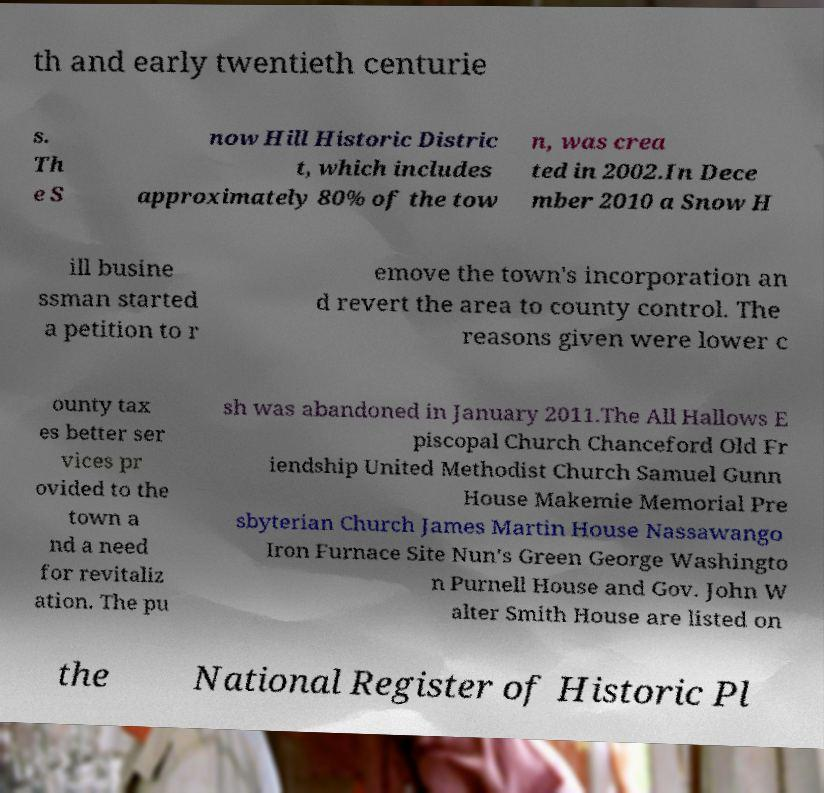Could you extract and type out the text from this image? th and early twentieth centurie s. Th e S now Hill Historic Distric t, which includes approximately 80% of the tow n, was crea ted in 2002.In Dece mber 2010 a Snow H ill busine ssman started a petition to r emove the town's incorporation an d revert the area to county control. The reasons given were lower c ounty tax es better ser vices pr ovided to the town a nd a need for revitaliz ation. The pu sh was abandoned in January 2011.The All Hallows E piscopal Church Chanceford Old Fr iendship United Methodist Church Samuel Gunn House Makemie Memorial Pre sbyterian Church James Martin House Nassawango Iron Furnace Site Nun's Green George Washingto n Purnell House and Gov. John W alter Smith House are listed on the National Register of Historic Pl 